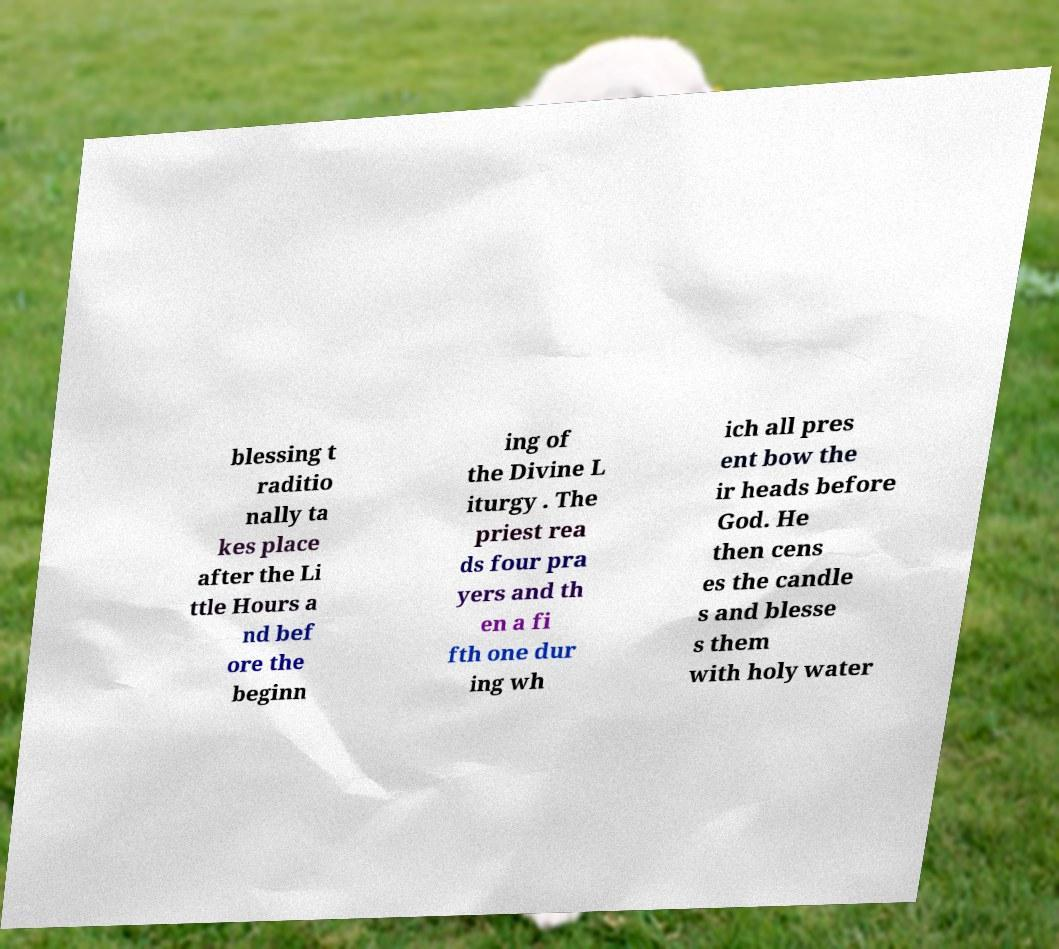Please read and relay the text visible in this image. What does it say? blessing t raditio nally ta kes place after the Li ttle Hours a nd bef ore the beginn ing of the Divine L iturgy . The priest rea ds four pra yers and th en a fi fth one dur ing wh ich all pres ent bow the ir heads before God. He then cens es the candle s and blesse s them with holy water 